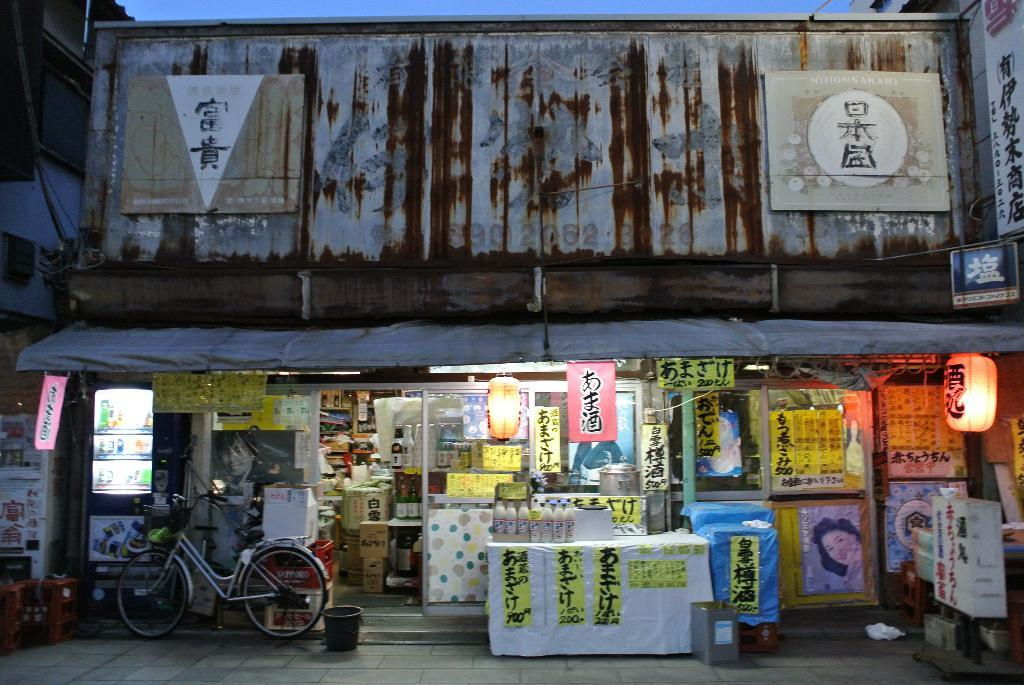<image>
Create a compact narrative representing the image presented. A sign at the upper right of the building starts with N and ends with A. 